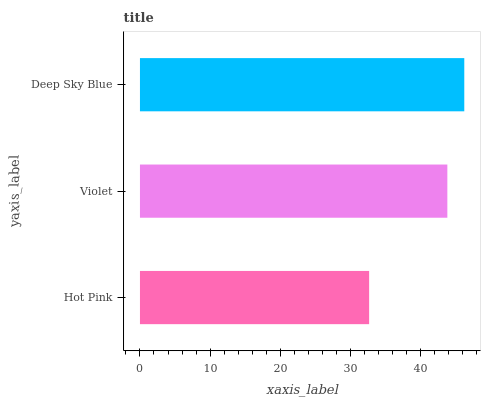Is Hot Pink the minimum?
Answer yes or no. Yes. Is Deep Sky Blue the maximum?
Answer yes or no. Yes. Is Violet the minimum?
Answer yes or no. No. Is Violet the maximum?
Answer yes or no. No. Is Violet greater than Hot Pink?
Answer yes or no. Yes. Is Hot Pink less than Violet?
Answer yes or no. Yes. Is Hot Pink greater than Violet?
Answer yes or no. No. Is Violet less than Hot Pink?
Answer yes or no. No. Is Violet the high median?
Answer yes or no. Yes. Is Violet the low median?
Answer yes or no. Yes. Is Deep Sky Blue the high median?
Answer yes or no. No. Is Hot Pink the low median?
Answer yes or no. No. 